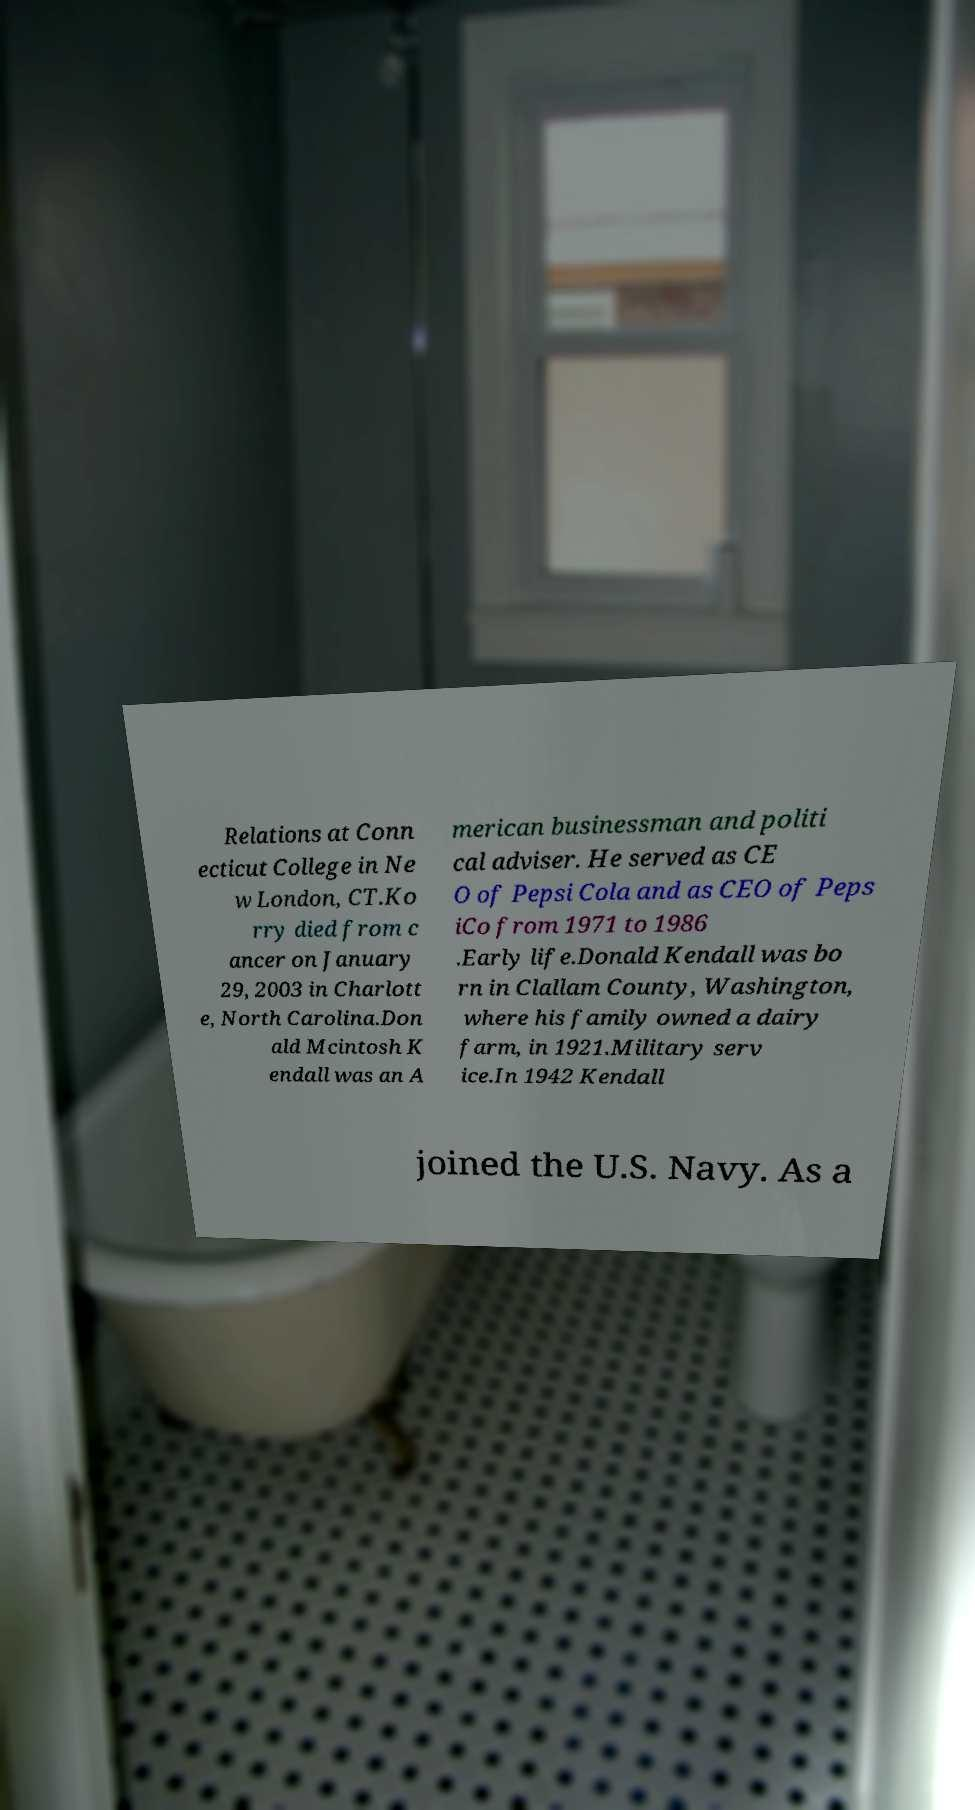For documentation purposes, I need the text within this image transcribed. Could you provide that? Relations at Conn ecticut College in Ne w London, CT.Ko rry died from c ancer on January 29, 2003 in Charlott e, North Carolina.Don ald Mcintosh K endall was an A merican businessman and politi cal adviser. He served as CE O of Pepsi Cola and as CEO of Peps iCo from 1971 to 1986 .Early life.Donald Kendall was bo rn in Clallam County, Washington, where his family owned a dairy farm, in 1921.Military serv ice.In 1942 Kendall joined the U.S. Navy. As a 